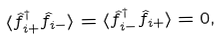Convert formula to latex. <formula><loc_0><loc_0><loc_500><loc_500>\langle \hat { f } _ { i + } ^ { \dagger } \hat { f } _ { i - } \rangle = \langle \hat { f } _ { i - } ^ { \dagger } \hat { f } _ { i + } \rangle = 0 ,</formula> 